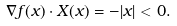Convert formula to latex. <formula><loc_0><loc_0><loc_500><loc_500>\nabla f ( x ) \cdot X ( x ) = - | x | < 0 .</formula> 